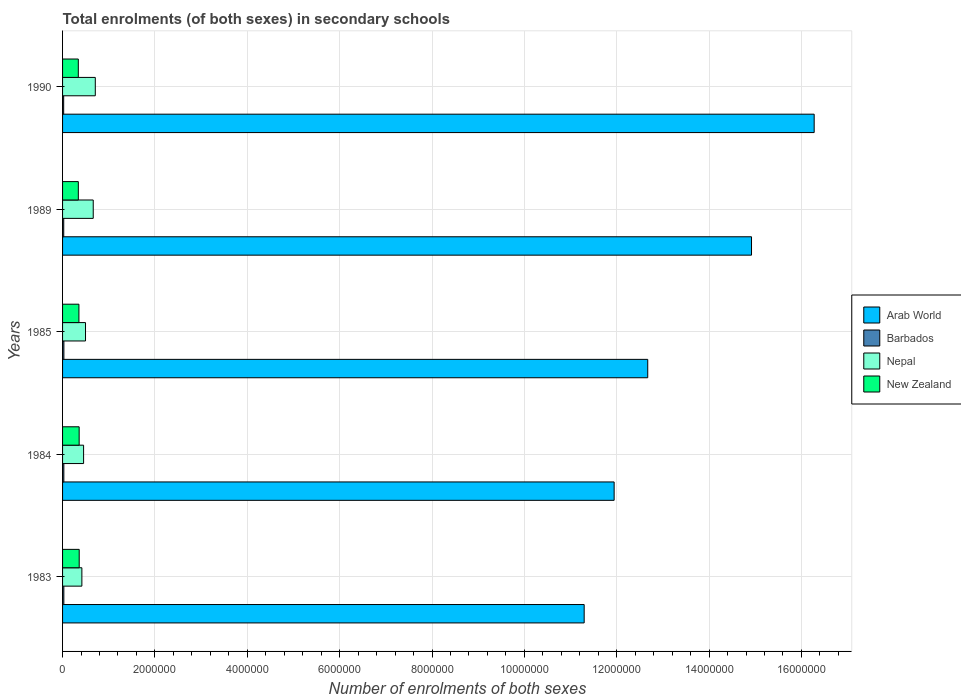How many different coloured bars are there?
Give a very brief answer. 4. How many bars are there on the 3rd tick from the top?
Provide a succinct answer. 4. How many bars are there on the 5th tick from the bottom?
Give a very brief answer. 4. In how many cases, is the number of bars for a given year not equal to the number of legend labels?
Give a very brief answer. 0. What is the number of enrolments in secondary schools in New Zealand in 1984?
Give a very brief answer. 3.59e+05. Across all years, what is the maximum number of enrolments in secondary schools in Arab World?
Offer a terse response. 1.63e+07. Across all years, what is the minimum number of enrolments in secondary schools in Arab World?
Your answer should be compact. 1.13e+07. In which year was the number of enrolments in secondary schools in Arab World minimum?
Make the answer very short. 1983. What is the total number of enrolments in secondary schools in New Zealand in the graph?
Give a very brief answer. 1.76e+06. What is the difference between the number of enrolments in secondary schools in Barbados in 1983 and that in 1984?
Your answer should be very brief. -75. What is the difference between the number of enrolments in secondary schools in New Zealand in 1989 and the number of enrolments in secondary schools in Arab World in 1984?
Your answer should be very brief. -1.16e+07. What is the average number of enrolments in secondary schools in Nepal per year?
Make the answer very short. 5.49e+05. In the year 1990, what is the difference between the number of enrolments in secondary schools in Arab World and number of enrolments in secondary schools in New Zealand?
Make the answer very short. 1.59e+07. In how many years, is the number of enrolments in secondary schools in Arab World greater than 8800000 ?
Keep it short and to the point. 5. What is the ratio of the number of enrolments in secondary schools in Arab World in 1983 to that in 1985?
Keep it short and to the point. 0.89. Is the number of enrolments in secondary schools in Nepal in 1985 less than that in 1990?
Keep it short and to the point. Yes. What is the difference between the highest and the second highest number of enrolments in secondary schools in Nepal?
Keep it short and to the point. 4.46e+04. What is the difference between the highest and the lowest number of enrolments in secondary schools in New Zealand?
Offer a very short reply. 1.95e+04. Is it the case that in every year, the sum of the number of enrolments in secondary schools in New Zealand and number of enrolments in secondary schools in Arab World is greater than the sum of number of enrolments in secondary schools in Barbados and number of enrolments in secondary schools in Nepal?
Offer a very short reply. Yes. What does the 3rd bar from the top in 1984 represents?
Give a very brief answer. Barbados. What does the 1st bar from the bottom in 1989 represents?
Your response must be concise. Arab World. Are all the bars in the graph horizontal?
Provide a succinct answer. Yes. What is the difference between two consecutive major ticks on the X-axis?
Keep it short and to the point. 2.00e+06. Are the values on the major ticks of X-axis written in scientific E-notation?
Your answer should be very brief. No. Does the graph contain grids?
Provide a succinct answer. Yes. How many legend labels are there?
Make the answer very short. 4. What is the title of the graph?
Provide a succinct answer. Total enrolments (of both sexes) in secondary schools. What is the label or title of the X-axis?
Your answer should be very brief. Number of enrolments of both sexes. What is the label or title of the Y-axis?
Offer a terse response. Years. What is the Number of enrolments of both sexes in Arab World in 1983?
Your answer should be compact. 1.13e+07. What is the Number of enrolments of both sexes of Barbados in 1983?
Keep it short and to the point. 2.76e+04. What is the Number of enrolments of both sexes in Nepal in 1983?
Keep it short and to the point. 4.18e+05. What is the Number of enrolments of both sexes of New Zealand in 1983?
Your answer should be very brief. 3.60e+05. What is the Number of enrolments of both sexes in Arab World in 1984?
Keep it short and to the point. 1.19e+07. What is the Number of enrolments of both sexes in Barbados in 1984?
Offer a very short reply. 2.77e+04. What is the Number of enrolments of both sexes of Nepal in 1984?
Keep it short and to the point. 4.55e+05. What is the Number of enrolments of both sexes of New Zealand in 1984?
Ensure brevity in your answer.  3.59e+05. What is the Number of enrolments of both sexes in Arab World in 1985?
Offer a very short reply. 1.27e+07. What is the Number of enrolments of both sexes in Barbados in 1985?
Give a very brief answer. 2.87e+04. What is the Number of enrolments of both sexes in Nepal in 1985?
Your answer should be compact. 4.97e+05. What is the Number of enrolments of both sexes of New Zealand in 1985?
Make the answer very short. 3.54e+05. What is the Number of enrolments of both sexes in Arab World in 1989?
Keep it short and to the point. 1.49e+07. What is the Number of enrolments of both sexes in Barbados in 1989?
Offer a terse response. 2.54e+04. What is the Number of enrolments of both sexes of Nepal in 1989?
Keep it short and to the point. 6.64e+05. What is the Number of enrolments of both sexes in New Zealand in 1989?
Ensure brevity in your answer.  3.41e+05. What is the Number of enrolments of both sexes in Arab World in 1990?
Keep it short and to the point. 1.63e+07. What is the Number of enrolments of both sexes in Barbados in 1990?
Provide a succinct answer. 2.40e+04. What is the Number of enrolments of both sexes of Nepal in 1990?
Offer a very short reply. 7.09e+05. What is the Number of enrolments of both sexes of New Zealand in 1990?
Your answer should be compact. 3.41e+05. Across all years, what is the maximum Number of enrolments of both sexes of Arab World?
Your answer should be very brief. 1.63e+07. Across all years, what is the maximum Number of enrolments of both sexes in Barbados?
Offer a very short reply. 2.87e+04. Across all years, what is the maximum Number of enrolments of both sexes in Nepal?
Your response must be concise. 7.09e+05. Across all years, what is the maximum Number of enrolments of both sexes of New Zealand?
Ensure brevity in your answer.  3.60e+05. Across all years, what is the minimum Number of enrolments of both sexes of Arab World?
Your response must be concise. 1.13e+07. Across all years, what is the minimum Number of enrolments of both sexes of Barbados?
Provide a short and direct response. 2.40e+04. Across all years, what is the minimum Number of enrolments of both sexes of Nepal?
Provide a succinct answer. 4.18e+05. Across all years, what is the minimum Number of enrolments of both sexes of New Zealand?
Your answer should be compact. 3.41e+05. What is the total Number of enrolments of both sexes of Arab World in the graph?
Your answer should be very brief. 6.71e+07. What is the total Number of enrolments of both sexes of Barbados in the graph?
Make the answer very short. 1.33e+05. What is the total Number of enrolments of both sexes of Nepal in the graph?
Give a very brief answer. 2.74e+06. What is the total Number of enrolments of both sexes in New Zealand in the graph?
Provide a succinct answer. 1.76e+06. What is the difference between the Number of enrolments of both sexes of Arab World in 1983 and that in 1984?
Give a very brief answer. -6.49e+05. What is the difference between the Number of enrolments of both sexes of Barbados in 1983 and that in 1984?
Offer a terse response. -75. What is the difference between the Number of enrolments of both sexes in Nepal in 1983 and that in 1984?
Keep it short and to the point. -3.73e+04. What is the difference between the Number of enrolments of both sexes in New Zealand in 1983 and that in 1984?
Give a very brief answer. 1080. What is the difference between the Number of enrolments of both sexes of Arab World in 1983 and that in 1985?
Make the answer very short. -1.38e+06. What is the difference between the Number of enrolments of both sexes in Barbados in 1983 and that in 1985?
Give a very brief answer. -1055. What is the difference between the Number of enrolments of both sexes in Nepal in 1983 and that in 1985?
Your response must be concise. -7.88e+04. What is the difference between the Number of enrolments of both sexes in New Zealand in 1983 and that in 1985?
Provide a short and direct response. 6331. What is the difference between the Number of enrolments of both sexes in Arab World in 1983 and that in 1989?
Ensure brevity in your answer.  -3.62e+06. What is the difference between the Number of enrolments of both sexes of Barbados in 1983 and that in 1989?
Offer a terse response. 2218. What is the difference between the Number of enrolments of both sexes of Nepal in 1983 and that in 1989?
Offer a very short reply. -2.46e+05. What is the difference between the Number of enrolments of both sexes of New Zealand in 1983 and that in 1989?
Offer a terse response. 1.92e+04. What is the difference between the Number of enrolments of both sexes in Arab World in 1983 and that in 1990?
Make the answer very short. -4.98e+06. What is the difference between the Number of enrolments of both sexes of Barbados in 1983 and that in 1990?
Your response must be concise. 3636. What is the difference between the Number of enrolments of both sexes of Nepal in 1983 and that in 1990?
Your response must be concise. -2.91e+05. What is the difference between the Number of enrolments of both sexes in New Zealand in 1983 and that in 1990?
Provide a succinct answer. 1.95e+04. What is the difference between the Number of enrolments of both sexes in Arab World in 1984 and that in 1985?
Provide a short and direct response. -7.28e+05. What is the difference between the Number of enrolments of both sexes of Barbados in 1984 and that in 1985?
Ensure brevity in your answer.  -980. What is the difference between the Number of enrolments of both sexes of Nepal in 1984 and that in 1985?
Ensure brevity in your answer.  -4.15e+04. What is the difference between the Number of enrolments of both sexes in New Zealand in 1984 and that in 1985?
Keep it short and to the point. 5251. What is the difference between the Number of enrolments of both sexes of Arab World in 1984 and that in 1989?
Your response must be concise. -2.98e+06. What is the difference between the Number of enrolments of both sexes of Barbados in 1984 and that in 1989?
Ensure brevity in your answer.  2293. What is the difference between the Number of enrolments of both sexes of Nepal in 1984 and that in 1989?
Your answer should be very brief. -2.09e+05. What is the difference between the Number of enrolments of both sexes in New Zealand in 1984 and that in 1989?
Offer a very short reply. 1.81e+04. What is the difference between the Number of enrolments of both sexes in Arab World in 1984 and that in 1990?
Give a very brief answer. -4.33e+06. What is the difference between the Number of enrolments of both sexes in Barbados in 1984 and that in 1990?
Offer a terse response. 3711. What is the difference between the Number of enrolments of both sexes of Nepal in 1984 and that in 1990?
Ensure brevity in your answer.  -2.53e+05. What is the difference between the Number of enrolments of both sexes in New Zealand in 1984 and that in 1990?
Make the answer very short. 1.84e+04. What is the difference between the Number of enrolments of both sexes in Arab World in 1985 and that in 1989?
Your answer should be compact. -2.25e+06. What is the difference between the Number of enrolments of both sexes of Barbados in 1985 and that in 1989?
Offer a very short reply. 3273. What is the difference between the Number of enrolments of both sexes of Nepal in 1985 and that in 1989?
Offer a very short reply. -1.67e+05. What is the difference between the Number of enrolments of both sexes of New Zealand in 1985 and that in 1989?
Provide a short and direct response. 1.28e+04. What is the difference between the Number of enrolments of both sexes of Arab World in 1985 and that in 1990?
Keep it short and to the point. -3.60e+06. What is the difference between the Number of enrolments of both sexes in Barbados in 1985 and that in 1990?
Offer a terse response. 4691. What is the difference between the Number of enrolments of both sexes in Nepal in 1985 and that in 1990?
Ensure brevity in your answer.  -2.12e+05. What is the difference between the Number of enrolments of both sexes of New Zealand in 1985 and that in 1990?
Offer a very short reply. 1.32e+04. What is the difference between the Number of enrolments of both sexes of Arab World in 1989 and that in 1990?
Provide a short and direct response. -1.36e+06. What is the difference between the Number of enrolments of both sexes of Barbados in 1989 and that in 1990?
Give a very brief answer. 1418. What is the difference between the Number of enrolments of both sexes in Nepal in 1989 and that in 1990?
Provide a short and direct response. -4.46e+04. What is the difference between the Number of enrolments of both sexes of New Zealand in 1989 and that in 1990?
Offer a terse response. 334. What is the difference between the Number of enrolments of both sexes of Arab World in 1983 and the Number of enrolments of both sexes of Barbados in 1984?
Ensure brevity in your answer.  1.13e+07. What is the difference between the Number of enrolments of both sexes in Arab World in 1983 and the Number of enrolments of both sexes in Nepal in 1984?
Provide a succinct answer. 1.08e+07. What is the difference between the Number of enrolments of both sexes of Arab World in 1983 and the Number of enrolments of both sexes of New Zealand in 1984?
Make the answer very short. 1.09e+07. What is the difference between the Number of enrolments of both sexes in Barbados in 1983 and the Number of enrolments of both sexes in Nepal in 1984?
Provide a short and direct response. -4.28e+05. What is the difference between the Number of enrolments of both sexes of Barbados in 1983 and the Number of enrolments of both sexes of New Zealand in 1984?
Your answer should be compact. -3.32e+05. What is the difference between the Number of enrolments of both sexes in Nepal in 1983 and the Number of enrolments of both sexes in New Zealand in 1984?
Your answer should be very brief. 5.88e+04. What is the difference between the Number of enrolments of both sexes in Arab World in 1983 and the Number of enrolments of both sexes in Barbados in 1985?
Keep it short and to the point. 1.13e+07. What is the difference between the Number of enrolments of both sexes in Arab World in 1983 and the Number of enrolments of both sexes in Nepal in 1985?
Give a very brief answer. 1.08e+07. What is the difference between the Number of enrolments of both sexes in Arab World in 1983 and the Number of enrolments of both sexes in New Zealand in 1985?
Provide a short and direct response. 1.09e+07. What is the difference between the Number of enrolments of both sexes in Barbados in 1983 and the Number of enrolments of both sexes in Nepal in 1985?
Your response must be concise. -4.69e+05. What is the difference between the Number of enrolments of both sexes in Barbados in 1983 and the Number of enrolments of both sexes in New Zealand in 1985?
Your answer should be compact. -3.26e+05. What is the difference between the Number of enrolments of both sexes of Nepal in 1983 and the Number of enrolments of both sexes of New Zealand in 1985?
Make the answer very short. 6.40e+04. What is the difference between the Number of enrolments of both sexes in Arab World in 1983 and the Number of enrolments of both sexes in Barbados in 1989?
Offer a terse response. 1.13e+07. What is the difference between the Number of enrolments of both sexes in Arab World in 1983 and the Number of enrolments of both sexes in Nepal in 1989?
Your answer should be compact. 1.06e+07. What is the difference between the Number of enrolments of both sexes of Arab World in 1983 and the Number of enrolments of both sexes of New Zealand in 1989?
Offer a very short reply. 1.10e+07. What is the difference between the Number of enrolments of both sexes in Barbados in 1983 and the Number of enrolments of both sexes in Nepal in 1989?
Keep it short and to the point. -6.36e+05. What is the difference between the Number of enrolments of both sexes in Barbados in 1983 and the Number of enrolments of both sexes in New Zealand in 1989?
Provide a short and direct response. -3.14e+05. What is the difference between the Number of enrolments of both sexes in Nepal in 1983 and the Number of enrolments of both sexes in New Zealand in 1989?
Provide a short and direct response. 7.68e+04. What is the difference between the Number of enrolments of both sexes in Arab World in 1983 and the Number of enrolments of both sexes in Barbados in 1990?
Your answer should be compact. 1.13e+07. What is the difference between the Number of enrolments of both sexes in Arab World in 1983 and the Number of enrolments of both sexes in Nepal in 1990?
Give a very brief answer. 1.06e+07. What is the difference between the Number of enrolments of both sexes of Arab World in 1983 and the Number of enrolments of both sexes of New Zealand in 1990?
Provide a short and direct response. 1.10e+07. What is the difference between the Number of enrolments of both sexes in Barbados in 1983 and the Number of enrolments of both sexes in Nepal in 1990?
Keep it short and to the point. -6.81e+05. What is the difference between the Number of enrolments of both sexes of Barbados in 1983 and the Number of enrolments of both sexes of New Zealand in 1990?
Offer a very short reply. -3.13e+05. What is the difference between the Number of enrolments of both sexes in Nepal in 1983 and the Number of enrolments of both sexes in New Zealand in 1990?
Your answer should be very brief. 7.72e+04. What is the difference between the Number of enrolments of both sexes in Arab World in 1984 and the Number of enrolments of both sexes in Barbados in 1985?
Provide a succinct answer. 1.19e+07. What is the difference between the Number of enrolments of both sexes of Arab World in 1984 and the Number of enrolments of both sexes of Nepal in 1985?
Your answer should be very brief. 1.14e+07. What is the difference between the Number of enrolments of both sexes in Arab World in 1984 and the Number of enrolments of both sexes in New Zealand in 1985?
Make the answer very short. 1.16e+07. What is the difference between the Number of enrolments of both sexes of Barbados in 1984 and the Number of enrolments of both sexes of Nepal in 1985?
Provide a succinct answer. -4.69e+05. What is the difference between the Number of enrolments of both sexes in Barbados in 1984 and the Number of enrolments of both sexes in New Zealand in 1985?
Your response must be concise. -3.26e+05. What is the difference between the Number of enrolments of both sexes in Nepal in 1984 and the Number of enrolments of both sexes in New Zealand in 1985?
Provide a succinct answer. 1.01e+05. What is the difference between the Number of enrolments of both sexes in Arab World in 1984 and the Number of enrolments of both sexes in Barbados in 1989?
Keep it short and to the point. 1.19e+07. What is the difference between the Number of enrolments of both sexes of Arab World in 1984 and the Number of enrolments of both sexes of Nepal in 1989?
Offer a terse response. 1.13e+07. What is the difference between the Number of enrolments of both sexes of Arab World in 1984 and the Number of enrolments of both sexes of New Zealand in 1989?
Give a very brief answer. 1.16e+07. What is the difference between the Number of enrolments of both sexes in Barbados in 1984 and the Number of enrolments of both sexes in Nepal in 1989?
Offer a terse response. -6.36e+05. What is the difference between the Number of enrolments of both sexes of Barbados in 1984 and the Number of enrolments of both sexes of New Zealand in 1989?
Keep it short and to the point. -3.14e+05. What is the difference between the Number of enrolments of both sexes of Nepal in 1984 and the Number of enrolments of both sexes of New Zealand in 1989?
Give a very brief answer. 1.14e+05. What is the difference between the Number of enrolments of both sexes in Arab World in 1984 and the Number of enrolments of both sexes in Barbados in 1990?
Provide a short and direct response. 1.19e+07. What is the difference between the Number of enrolments of both sexes in Arab World in 1984 and the Number of enrolments of both sexes in Nepal in 1990?
Give a very brief answer. 1.12e+07. What is the difference between the Number of enrolments of both sexes of Arab World in 1984 and the Number of enrolments of both sexes of New Zealand in 1990?
Make the answer very short. 1.16e+07. What is the difference between the Number of enrolments of both sexes of Barbados in 1984 and the Number of enrolments of both sexes of Nepal in 1990?
Make the answer very short. -6.81e+05. What is the difference between the Number of enrolments of both sexes in Barbados in 1984 and the Number of enrolments of both sexes in New Zealand in 1990?
Give a very brief answer. -3.13e+05. What is the difference between the Number of enrolments of both sexes of Nepal in 1984 and the Number of enrolments of both sexes of New Zealand in 1990?
Offer a terse response. 1.14e+05. What is the difference between the Number of enrolments of both sexes in Arab World in 1985 and the Number of enrolments of both sexes in Barbados in 1989?
Provide a short and direct response. 1.26e+07. What is the difference between the Number of enrolments of both sexes of Arab World in 1985 and the Number of enrolments of both sexes of Nepal in 1989?
Keep it short and to the point. 1.20e+07. What is the difference between the Number of enrolments of both sexes in Arab World in 1985 and the Number of enrolments of both sexes in New Zealand in 1989?
Make the answer very short. 1.23e+07. What is the difference between the Number of enrolments of both sexes in Barbados in 1985 and the Number of enrolments of both sexes in Nepal in 1989?
Your answer should be very brief. -6.35e+05. What is the difference between the Number of enrolments of both sexes of Barbados in 1985 and the Number of enrolments of both sexes of New Zealand in 1989?
Keep it short and to the point. -3.13e+05. What is the difference between the Number of enrolments of both sexes in Nepal in 1985 and the Number of enrolments of both sexes in New Zealand in 1989?
Keep it short and to the point. 1.56e+05. What is the difference between the Number of enrolments of both sexes of Arab World in 1985 and the Number of enrolments of both sexes of Barbados in 1990?
Provide a succinct answer. 1.26e+07. What is the difference between the Number of enrolments of both sexes of Arab World in 1985 and the Number of enrolments of both sexes of Nepal in 1990?
Make the answer very short. 1.20e+07. What is the difference between the Number of enrolments of both sexes in Arab World in 1985 and the Number of enrolments of both sexes in New Zealand in 1990?
Your answer should be compact. 1.23e+07. What is the difference between the Number of enrolments of both sexes of Barbados in 1985 and the Number of enrolments of both sexes of Nepal in 1990?
Your answer should be very brief. -6.80e+05. What is the difference between the Number of enrolments of both sexes of Barbados in 1985 and the Number of enrolments of both sexes of New Zealand in 1990?
Offer a very short reply. -3.12e+05. What is the difference between the Number of enrolments of both sexes of Nepal in 1985 and the Number of enrolments of both sexes of New Zealand in 1990?
Your response must be concise. 1.56e+05. What is the difference between the Number of enrolments of both sexes of Arab World in 1989 and the Number of enrolments of both sexes of Barbados in 1990?
Make the answer very short. 1.49e+07. What is the difference between the Number of enrolments of both sexes of Arab World in 1989 and the Number of enrolments of both sexes of Nepal in 1990?
Your answer should be compact. 1.42e+07. What is the difference between the Number of enrolments of both sexes of Arab World in 1989 and the Number of enrolments of both sexes of New Zealand in 1990?
Make the answer very short. 1.46e+07. What is the difference between the Number of enrolments of both sexes in Barbados in 1989 and the Number of enrolments of both sexes in Nepal in 1990?
Keep it short and to the point. -6.83e+05. What is the difference between the Number of enrolments of both sexes in Barbados in 1989 and the Number of enrolments of both sexes in New Zealand in 1990?
Give a very brief answer. -3.15e+05. What is the difference between the Number of enrolments of both sexes in Nepal in 1989 and the Number of enrolments of both sexes in New Zealand in 1990?
Provide a succinct answer. 3.23e+05. What is the average Number of enrolments of both sexes in Arab World per year?
Offer a terse response. 1.34e+07. What is the average Number of enrolments of both sexes of Barbados per year?
Make the answer very short. 2.67e+04. What is the average Number of enrolments of both sexes in Nepal per year?
Offer a very short reply. 5.49e+05. What is the average Number of enrolments of both sexes of New Zealand per year?
Your answer should be very brief. 3.51e+05. In the year 1983, what is the difference between the Number of enrolments of both sexes of Arab World and Number of enrolments of both sexes of Barbados?
Your response must be concise. 1.13e+07. In the year 1983, what is the difference between the Number of enrolments of both sexes of Arab World and Number of enrolments of both sexes of Nepal?
Your response must be concise. 1.09e+07. In the year 1983, what is the difference between the Number of enrolments of both sexes in Arab World and Number of enrolments of both sexes in New Zealand?
Make the answer very short. 1.09e+07. In the year 1983, what is the difference between the Number of enrolments of both sexes of Barbados and Number of enrolments of both sexes of Nepal?
Keep it short and to the point. -3.90e+05. In the year 1983, what is the difference between the Number of enrolments of both sexes of Barbados and Number of enrolments of both sexes of New Zealand?
Provide a succinct answer. -3.33e+05. In the year 1983, what is the difference between the Number of enrolments of both sexes of Nepal and Number of enrolments of both sexes of New Zealand?
Your answer should be compact. 5.77e+04. In the year 1984, what is the difference between the Number of enrolments of both sexes in Arab World and Number of enrolments of both sexes in Barbados?
Give a very brief answer. 1.19e+07. In the year 1984, what is the difference between the Number of enrolments of both sexes of Arab World and Number of enrolments of both sexes of Nepal?
Offer a terse response. 1.15e+07. In the year 1984, what is the difference between the Number of enrolments of both sexes in Arab World and Number of enrolments of both sexes in New Zealand?
Your answer should be compact. 1.16e+07. In the year 1984, what is the difference between the Number of enrolments of both sexes of Barbados and Number of enrolments of both sexes of Nepal?
Offer a terse response. -4.28e+05. In the year 1984, what is the difference between the Number of enrolments of both sexes of Barbados and Number of enrolments of both sexes of New Zealand?
Your response must be concise. -3.32e+05. In the year 1984, what is the difference between the Number of enrolments of both sexes in Nepal and Number of enrolments of both sexes in New Zealand?
Ensure brevity in your answer.  9.61e+04. In the year 1985, what is the difference between the Number of enrolments of both sexes of Arab World and Number of enrolments of both sexes of Barbados?
Make the answer very short. 1.26e+07. In the year 1985, what is the difference between the Number of enrolments of both sexes of Arab World and Number of enrolments of both sexes of Nepal?
Give a very brief answer. 1.22e+07. In the year 1985, what is the difference between the Number of enrolments of both sexes in Arab World and Number of enrolments of both sexes in New Zealand?
Give a very brief answer. 1.23e+07. In the year 1985, what is the difference between the Number of enrolments of both sexes of Barbados and Number of enrolments of both sexes of Nepal?
Give a very brief answer. -4.68e+05. In the year 1985, what is the difference between the Number of enrolments of both sexes in Barbados and Number of enrolments of both sexes in New Zealand?
Provide a succinct answer. -3.25e+05. In the year 1985, what is the difference between the Number of enrolments of both sexes in Nepal and Number of enrolments of both sexes in New Zealand?
Provide a short and direct response. 1.43e+05. In the year 1989, what is the difference between the Number of enrolments of both sexes in Arab World and Number of enrolments of both sexes in Barbados?
Make the answer very short. 1.49e+07. In the year 1989, what is the difference between the Number of enrolments of both sexes of Arab World and Number of enrolments of both sexes of Nepal?
Offer a terse response. 1.43e+07. In the year 1989, what is the difference between the Number of enrolments of both sexes in Arab World and Number of enrolments of both sexes in New Zealand?
Provide a succinct answer. 1.46e+07. In the year 1989, what is the difference between the Number of enrolments of both sexes in Barbados and Number of enrolments of both sexes in Nepal?
Your answer should be very brief. -6.39e+05. In the year 1989, what is the difference between the Number of enrolments of both sexes of Barbados and Number of enrolments of both sexes of New Zealand?
Make the answer very short. -3.16e+05. In the year 1989, what is the difference between the Number of enrolments of both sexes of Nepal and Number of enrolments of both sexes of New Zealand?
Keep it short and to the point. 3.23e+05. In the year 1990, what is the difference between the Number of enrolments of both sexes of Arab World and Number of enrolments of both sexes of Barbados?
Your answer should be very brief. 1.63e+07. In the year 1990, what is the difference between the Number of enrolments of both sexes of Arab World and Number of enrolments of both sexes of Nepal?
Ensure brevity in your answer.  1.56e+07. In the year 1990, what is the difference between the Number of enrolments of both sexes of Arab World and Number of enrolments of both sexes of New Zealand?
Make the answer very short. 1.59e+07. In the year 1990, what is the difference between the Number of enrolments of both sexes of Barbados and Number of enrolments of both sexes of Nepal?
Provide a succinct answer. -6.85e+05. In the year 1990, what is the difference between the Number of enrolments of both sexes of Barbados and Number of enrolments of both sexes of New Zealand?
Give a very brief answer. -3.17e+05. In the year 1990, what is the difference between the Number of enrolments of both sexes of Nepal and Number of enrolments of both sexes of New Zealand?
Provide a short and direct response. 3.68e+05. What is the ratio of the Number of enrolments of both sexes of Arab World in 1983 to that in 1984?
Keep it short and to the point. 0.95. What is the ratio of the Number of enrolments of both sexes in Barbados in 1983 to that in 1984?
Provide a short and direct response. 1. What is the ratio of the Number of enrolments of both sexes in Nepal in 1983 to that in 1984?
Keep it short and to the point. 0.92. What is the ratio of the Number of enrolments of both sexes in Arab World in 1983 to that in 1985?
Your answer should be compact. 0.89. What is the ratio of the Number of enrolments of both sexes in Barbados in 1983 to that in 1985?
Your answer should be very brief. 0.96. What is the ratio of the Number of enrolments of both sexes of Nepal in 1983 to that in 1985?
Your answer should be compact. 0.84. What is the ratio of the Number of enrolments of both sexes of New Zealand in 1983 to that in 1985?
Offer a very short reply. 1.02. What is the ratio of the Number of enrolments of both sexes in Arab World in 1983 to that in 1989?
Offer a very short reply. 0.76. What is the ratio of the Number of enrolments of both sexes in Barbados in 1983 to that in 1989?
Ensure brevity in your answer.  1.09. What is the ratio of the Number of enrolments of both sexes of Nepal in 1983 to that in 1989?
Provide a succinct answer. 0.63. What is the ratio of the Number of enrolments of both sexes in New Zealand in 1983 to that in 1989?
Keep it short and to the point. 1.06. What is the ratio of the Number of enrolments of both sexes of Arab World in 1983 to that in 1990?
Keep it short and to the point. 0.69. What is the ratio of the Number of enrolments of both sexes in Barbados in 1983 to that in 1990?
Provide a short and direct response. 1.15. What is the ratio of the Number of enrolments of both sexes in Nepal in 1983 to that in 1990?
Give a very brief answer. 0.59. What is the ratio of the Number of enrolments of both sexes of New Zealand in 1983 to that in 1990?
Provide a short and direct response. 1.06. What is the ratio of the Number of enrolments of both sexes in Arab World in 1984 to that in 1985?
Keep it short and to the point. 0.94. What is the ratio of the Number of enrolments of both sexes of Barbados in 1984 to that in 1985?
Offer a very short reply. 0.97. What is the ratio of the Number of enrolments of both sexes in Nepal in 1984 to that in 1985?
Give a very brief answer. 0.92. What is the ratio of the Number of enrolments of both sexes in New Zealand in 1984 to that in 1985?
Offer a terse response. 1.01. What is the ratio of the Number of enrolments of both sexes in Arab World in 1984 to that in 1989?
Provide a succinct answer. 0.8. What is the ratio of the Number of enrolments of both sexes of Barbados in 1984 to that in 1989?
Offer a very short reply. 1.09. What is the ratio of the Number of enrolments of both sexes in Nepal in 1984 to that in 1989?
Keep it short and to the point. 0.69. What is the ratio of the Number of enrolments of both sexes of New Zealand in 1984 to that in 1989?
Your answer should be very brief. 1.05. What is the ratio of the Number of enrolments of both sexes of Arab World in 1984 to that in 1990?
Give a very brief answer. 0.73. What is the ratio of the Number of enrolments of both sexes in Barbados in 1984 to that in 1990?
Offer a very short reply. 1.15. What is the ratio of the Number of enrolments of both sexes of Nepal in 1984 to that in 1990?
Your response must be concise. 0.64. What is the ratio of the Number of enrolments of both sexes of New Zealand in 1984 to that in 1990?
Offer a terse response. 1.05. What is the ratio of the Number of enrolments of both sexes of Arab World in 1985 to that in 1989?
Give a very brief answer. 0.85. What is the ratio of the Number of enrolments of both sexes in Barbados in 1985 to that in 1989?
Your answer should be very brief. 1.13. What is the ratio of the Number of enrolments of both sexes of Nepal in 1985 to that in 1989?
Your response must be concise. 0.75. What is the ratio of the Number of enrolments of both sexes in New Zealand in 1985 to that in 1989?
Your response must be concise. 1.04. What is the ratio of the Number of enrolments of both sexes in Arab World in 1985 to that in 1990?
Ensure brevity in your answer.  0.78. What is the ratio of the Number of enrolments of both sexes of Barbados in 1985 to that in 1990?
Keep it short and to the point. 1.2. What is the ratio of the Number of enrolments of both sexes of Nepal in 1985 to that in 1990?
Offer a very short reply. 0.7. What is the ratio of the Number of enrolments of both sexes in New Zealand in 1985 to that in 1990?
Your answer should be very brief. 1.04. What is the ratio of the Number of enrolments of both sexes of Arab World in 1989 to that in 1990?
Offer a terse response. 0.92. What is the ratio of the Number of enrolments of both sexes of Barbados in 1989 to that in 1990?
Give a very brief answer. 1.06. What is the ratio of the Number of enrolments of both sexes in Nepal in 1989 to that in 1990?
Your answer should be compact. 0.94. What is the difference between the highest and the second highest Number of enrolments of both sexes of Arab World?
Provide a succinct answer. 1.36e+06. What is the difference between the highest and the second highest Number of enrolments of both sexes in Barbados?
Your response must be concise. 980. What is the difference between the highest and the second highest Number of enrolments of both sexes in Nepal?
Give a very brief answer. 4.46e+04. What is the difference between the highest and the second highest Number of enrolments of both sexes in New Zealand?
Offer a very short reply. 1080. What is the difference between the highest and the lowest Number of enrolments of both sexes in Arab World?
Ensure brevity in your answer.  4.98e+06. What is the difference between the highest and the lowest Number of enrolments of both sexes of Barbados?
Give a very brief answer. 4691. What is the difference between the highest and the lowest Number of enrolments of both sexes in Nepal?
Offer a very short reply. 2.91e+05. What is the difference between the highest and the lowest Number of enrolments of both sexes of New Zealand?
Ensure brevity in your answer.  1.95e+04. 